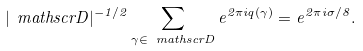<formula> <loc_0><loc_0><loc_500><loc_500>| \ m a t h s c r { D } | ^ { - 1 / 2 } \sum _ { \gamma \in \ m a t h s c r { D } } e ^ { 2 \pi i q ( \gamma ) } = e ^ { 2 \pi i \sigma / 8 } .</formula> 